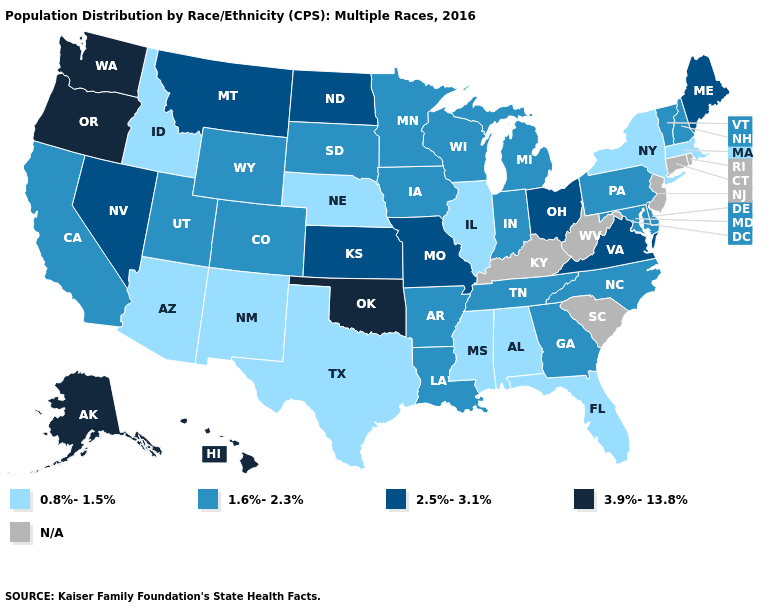Name the states that have a value in the range 3.9%-13.8%?
Short answer required. Alaska, Hawaii, Oklahoma, Oregon, Washington. Among the states that border Montana , does South Dakota have the highest value?
Give a very brief answer. No. Name the states that have a value in the range 0.8%-1.5%?
Short answer required. Alabama, Arizona, Florida, Idaho, Illinois, Massachusetts, Mississippi, Nebraska, New Mexico, New York, Texas. What is the value of Utah?
Short answer required. 1.6%-2.3%. Does the first symbol in the legend represent the smallest category?
Answer briefly. Yes. Name the states that have a value in the range 1.6%-2.3%?
Write a very short answer. Arkansas, California, Colorado, Delaware, Georgia, Indiana, Iowa, Louisiana, Maryland, Michigan, Minnesota, New Hampshire, North Carolina, Pennsylvania, South Dakota, Tennessee, Utah, Vermont, Wisconsin, Wyoming. What is the lowest value in the USA?
Keep it brief. 0.8%-1.5%. Among the states that border Vermont , which have the lowest value?
Quick response, please. Massachusetts, New York. What is the value of Vermont?
Concise answer only. 1.6%-2.3%. Does Michigan have the highest value in the MidWest?
Quick response, please. No. What is the highest value in the USA?
Write a very short answer. 3.9%-13.8%. Among the states that border Pennsylvania , which have the highest value?
Write a very short answer. Ohio. What is the highest value in the USA?
Be succinct. 3.9%-13.8%. Name the states that have a value in the range 2.5%-3.1%?
Be succinct. Kansas, Maine, Missouri, Montana, Nevada, North Dakota, Ohio, Virginia. 